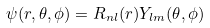<formula> <loc_0><loc_0><loc_500><loc_500>\psi ( r , \theta , \phi ) = R _ { n l } ( r ) Y _ { l m } ( \theta , \phi )</formula> 